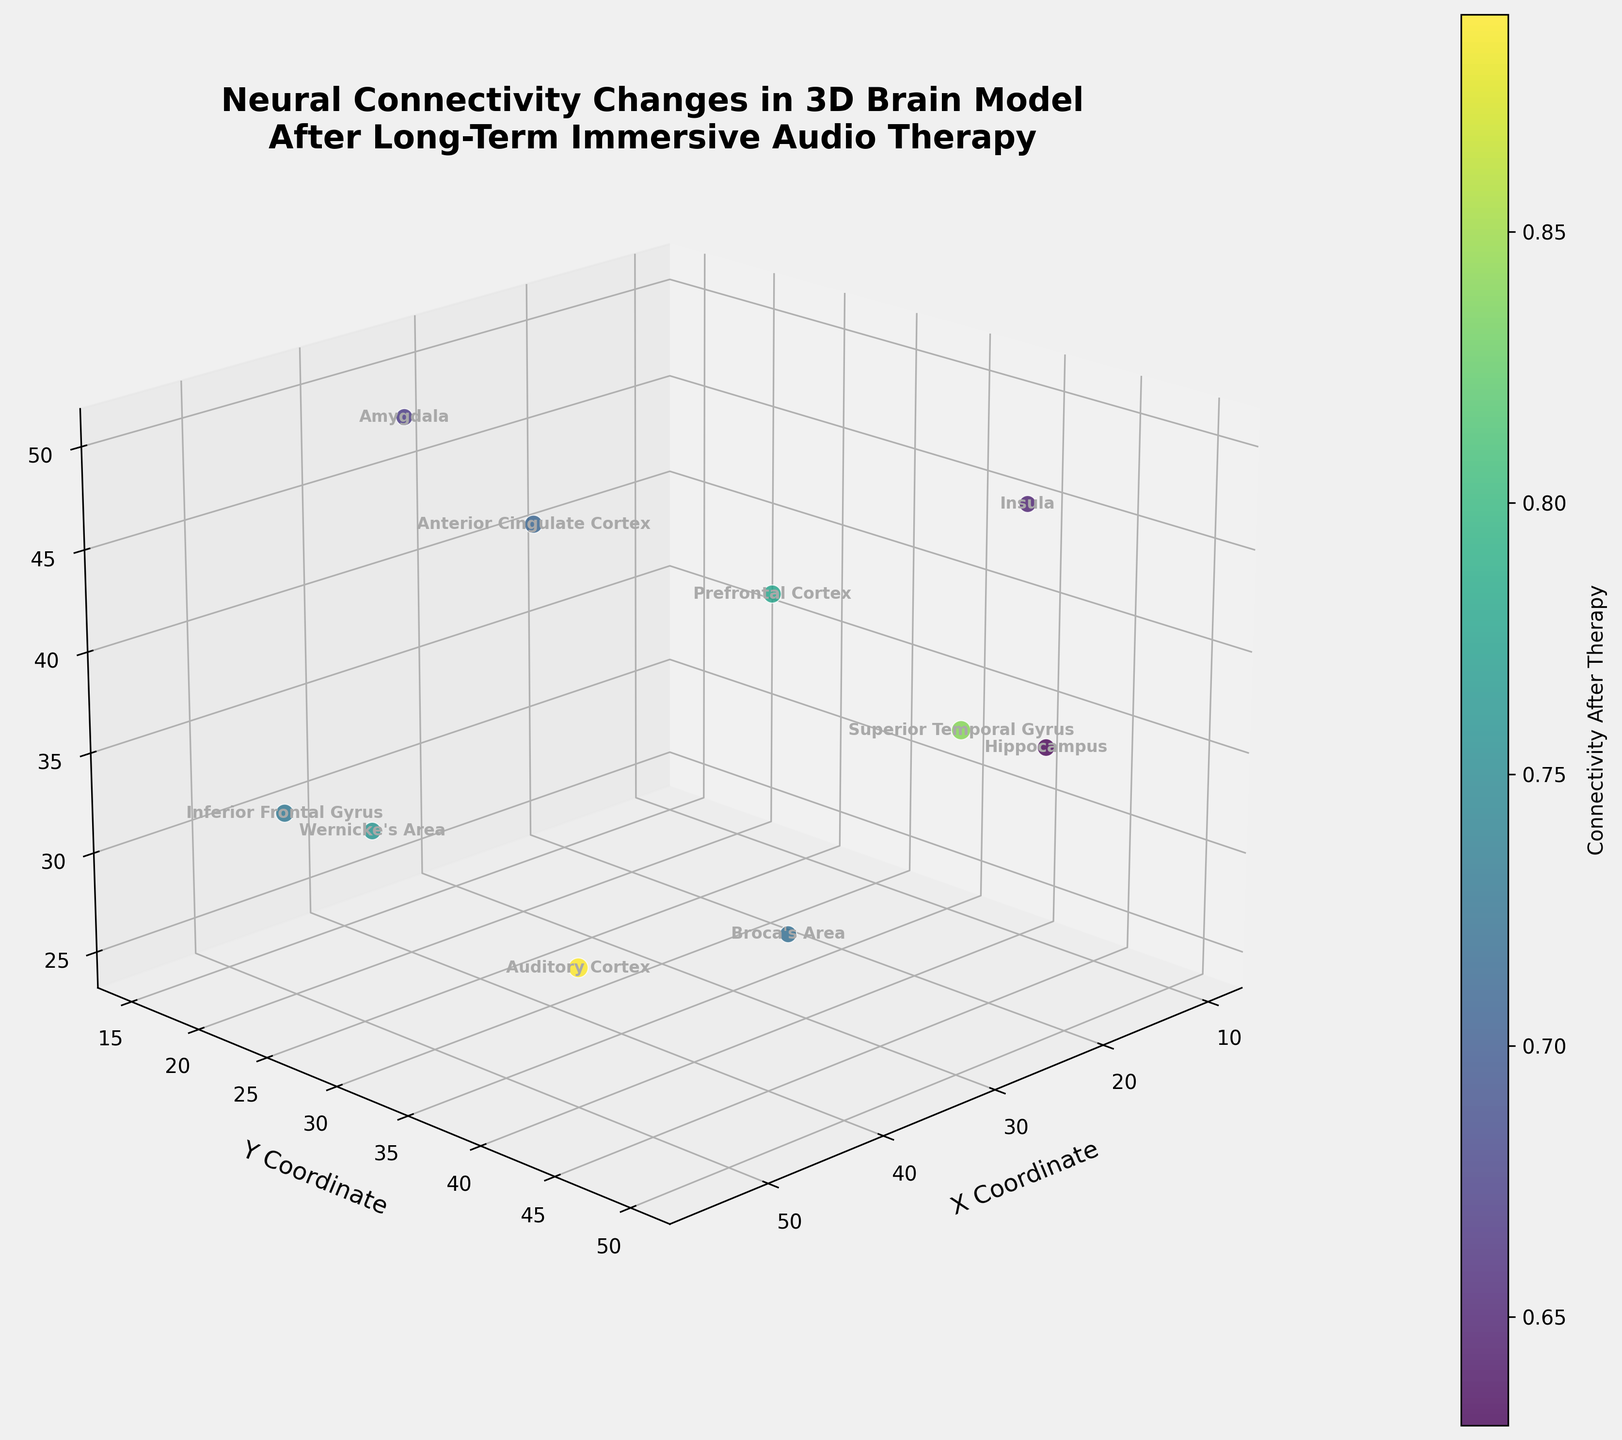What's the title of the 3D plot? The title is usually located above the plot and is often in larger, bold font to distinguish it from other text. In this case, the title is prominent and descriptive.
Answer: Neural Connectivity Changes in 3D Brain Model After Long-Term Immersive Audio Therapy How many brain regions are represented in the 3D plot? Count the number of unique data points or labels in the plot. Each point represents a different brain region, labeled clearly by name.
Answer: 10 Which brain region has the highest connectivity after therapy? Look for the brain region with the highest value for 'connectivity_after' in the plot. This is typically reflected by the color gradient and possibly the size of the data point.
Answer: Auditory Cortex What are the coordinates of the Prefrontal Cortex? Find the label for the Prefrontal Cortex and read off its x, y, and z values from the plot. Labels are positioned next to their respective data points.
Answer: (20, 30, 40) What is the average connectivity before therapy across all brain regions? Sum up the 'connectivity_before' values for all brain regions and divide by the total number of regions (10). The connectivity values are provided for reference.
Answer: (0.62 + 0.55 + 0.70 + 0.48 + 0.53 + 0.58 + 0.61 + 0.66 + 0.57 + 0.51) / 10 = 0.581 Which region shows the largest increase in connectivity after therapy? Calculate the difference between 'connectivity_after' and 'connectivity_before' for each region. Identify the region with the maximum difference.
Answer: Auditory Cortex How does the connectivity change in the Hippocampus compare to the Amygdala? Compute the connectivity changes (connectivity_after – connectivity_before) for both the Hippocampus and the Amygdala, and compare the two values.
Answer: 0.63 - 0.48 (Hippocampus) vs. 0.67 - 0.53 (Amygdala) = 0.15 vs. 0.14 Which regions have connectivity after therapy greater than 0.75? Identify the regions whose 'connectivity_after' values exceed 0.75. These can be distinguished using the color gradient and checking the values.
Answer: Prefrontal Cortex, Auditory Cortex, Superior Temporal Gyrus What is the median value of connectivity after therapy? Arrange the 'connectivity_after' values in numerical order and find the middle value. Since there are 10 values, the median is the average of the 5th and 6th values.
Answer: (0.72 + 0.73) / 2 = 0.725 What regions are located above the y-coordinate 40? Check the y-values of each region and list those which are greater than 40.
Answer: Hippocampus, Superior Temporal Gyrus, Insula 